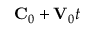<formula> <loc_0><loc_0><loc_500><loc_500>{ C } _ { 0 } + { V } _ { 0 } t</formula> 